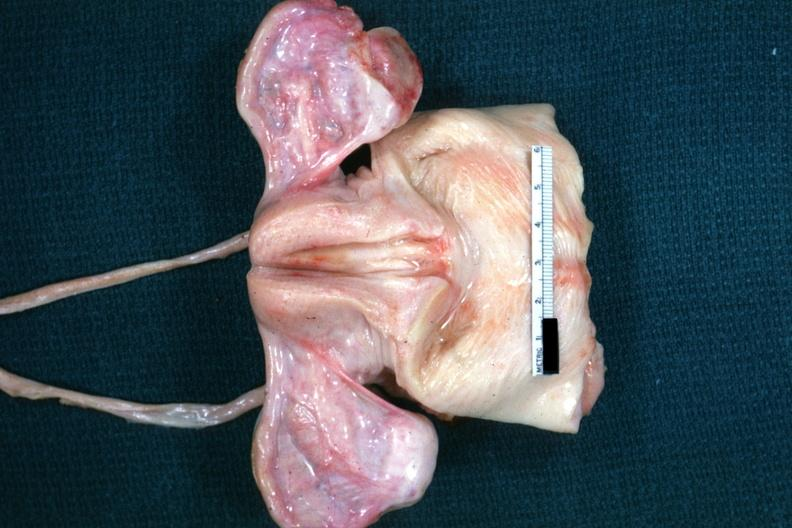s female reproductive present?
Answer the question using a single word or phrase. Yes 